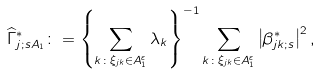<formula> <loc_0><loc_0><loc_500><loc_500>\widehat { \Gamma } _ { j ; s A _ { 1 } } ^ { \ast } \colon = \left \{ \sum _ { k \colon \xi _ { j k } \in A _ { 1 } ^ { \varepsilon } } \lambda _ { k } \right \} ^ { - 1 } \sum _ { k \colon \xi _ { j k } \in A _ { 1 } ^ { \varepsilon } } \left | \beta _ { j k ; s } ^ { \ast } \right | ^ { 2 } , \text { }</formula> 